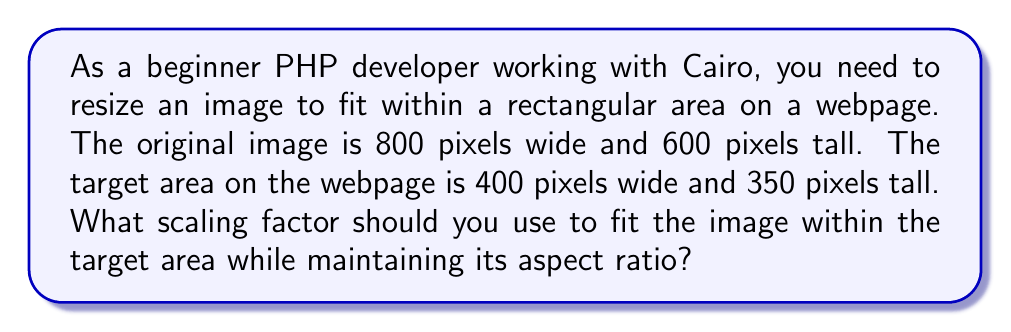Solve this math problem. To solve this problem, we need to follow these steps:

1. Calculate the aspect ratio of the original image:
   $$ \text{Aspect Ratio} = \frac{\text{Width}}{\text{Height}} = \frac{800}{600} = \frac{4}{3} $$

2. Calculate the scaling factors for both width and height:
   $$ \text{Width Scaling Factor} = \frac{\text{Target Width}}{\text{Original Width}} = \frac{400}{800} = 0.5 $$
   $$ \text{Height Scaling Factor} = \frac{\text{Target Height}}{\text{Original Height}} = \frac{350}{600} \approx 0.5833 $$

3. Choose the smaller scaling factor to ensure the image fits within the target area:
   $$ \text{Scaling Factor} = \min(0.5, 0.5833) = 0.5 $$

4. Verify the result:
   New width: $800 \times 0.5 = 400$ pixels (fits exactly)
   New height: $600 \times 0.5 = 300$ pixels (fits within 350 pixels)

The scaling factor of 0.5 ensures that the image fits within the target area while maintaining its original aspect ratio. In Cairo, you would use this scaling factor to resize the image before drawing it on the surface.
Answer: The scaling factor to fit the image within the specified rectangular area while maintaining its aspect ratio is 0.5. 